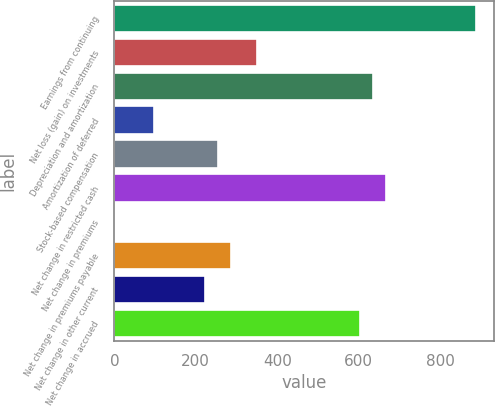Convert chart. <chart><loc_0><loc_0><loc_500><loc_500><bar_chart><fcel>Earnings from continuing<fcel>Net loss (gain) on investments<fcel>Depreciation and amortization<fcel>Amortization of deferred<fcel>Stock-based compensation<fcel>Net change in restricted cash<fcel>Net change in premiums<fcel>Net change in premiums payable<fcel>Net change in other current<fcel>Net change in accrued<nl><fcel>887.86<fcel>349.47<fcel>634.5<fcel>96.11<fcel>254.46<fcel>666.17<fcel>1.1<fcel>286.13<fcel>222.79<fcel>602.83<nl></chart> 